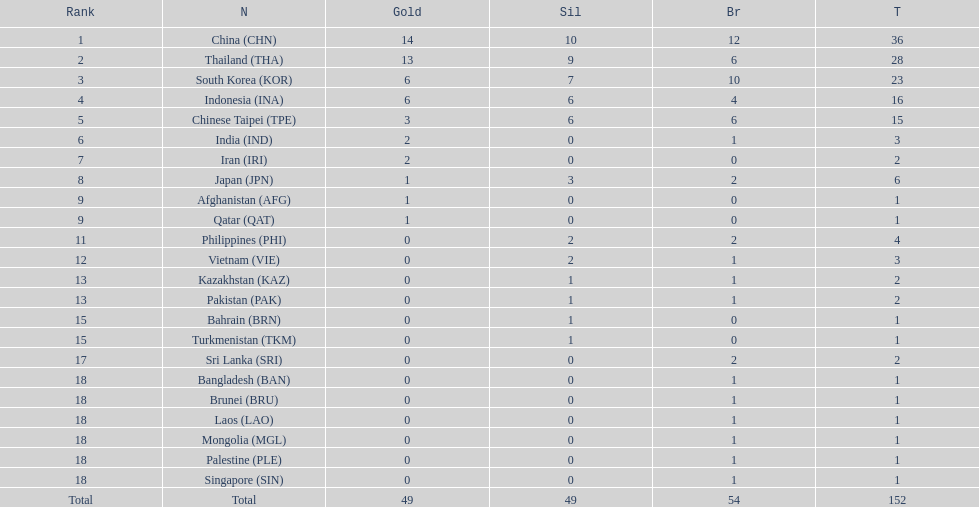How many nations received more than 5 gold medals? 4. Help me parse the entirety of this table. {'header': ['Rank', 'N', 'Gold', 'Sil', 'Br', 'T'], 'rows': [['1', 'China\xa0(CHN)', '14', '10', '12', '36'], ['2', 'Thailand\xa0(THA)', '13', '9', '6', '28'], ['3', 'South Korea\xa0(KOR)', '6', '7', '10', '23'], ['4', 'Indonesia\xa0(INA)', '6', '6', '4', '16'], ['5', 'Chinese Taipei\xa0(TPE)', '3', '6', '6', '15'], ['6', 'India\xa0(IND)', '2', '0', '1', '3'], ['7', 'Iran\xa0(IRI)', '2', '0', '0', '2'], ['8', 'Japan\xa0(JPN)', '1', '3', '2', '6'], ['9', 'Afghanistan\xa0(AFG)', '1', '0', '0', '1'], ['9', 'Qatar\xa0(QAT)', '1', '0', '0', '1'], ['11', 'Philippines\xa0(PHI)', '0', '2', '2', '4'], ['12', 'Vietnam\xa0(VIE)', '0', '2', '1', '3'], ['13', 'Kazakhstan\xa0(KAZ)', '0', '1', '1', '2'], ['13', 'Pakistan\xa0(PAK)', '0', '1', '1', '2'], ['15', 'Bahrain\xa0(BRN)', '0', '1', '0', '1'], ['15', 'Turkmenistan\xa0(TKM)', '0', '1', '0', '1'], ['17', 'Sri Lanka\xa0(SRI)', '0', '0', '2', '2'], ['18', 'Bangladesh\xa0(BAN)', '0', '0', '1', '1'], ['18', 'Brunei\xa0(BRU)', '0', '0', '1', '1'], ['18', 'Laos\xa0(LAO)', '0', '0', '1', '1'], ['18', 'Mongolia\xa0(MGL)', '0', '0', '1', '1'], ['18', 'Palestine\xa0(PLE)', '0', '0', '1', '1'], ['18', 'Singapore\xa0(SIN)', '0', '0', '1', '1'], ['Total', 'Total', '49', '49', '54', '152']]} 